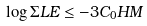Convert formula to latex. <formula><loc_0><loc_0><loc_500><loc_500>\log \Sigma L E \leq - 3 C _ { 0 } H M</formula> 